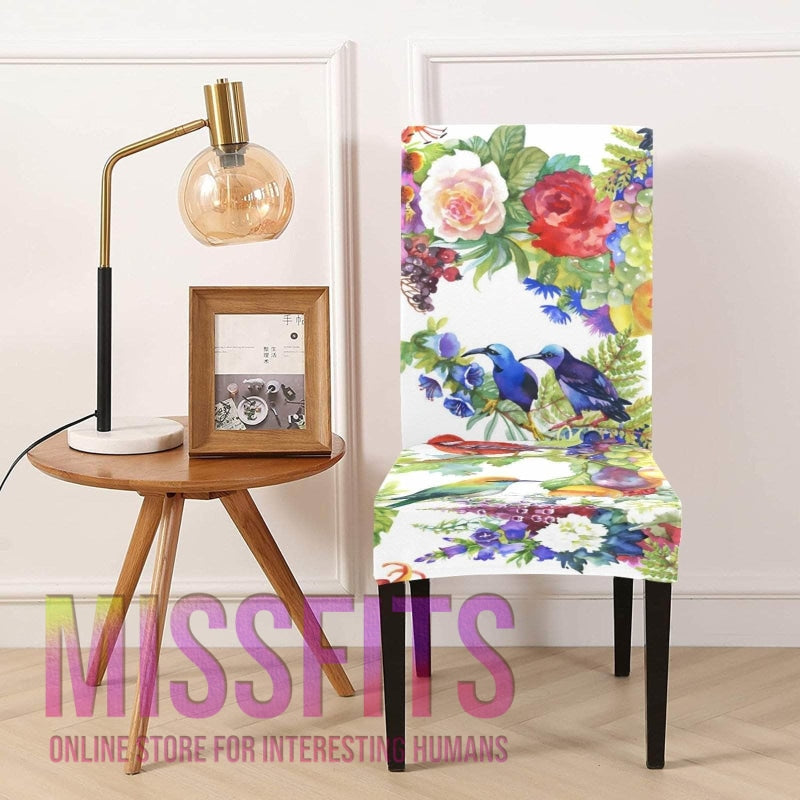How many chairs would there be in the image if someone deleted zero chair from the picture? If no chairs are deleted from the image, there would still be one chair present, decorated with a vibrant floral and avian pattern. 